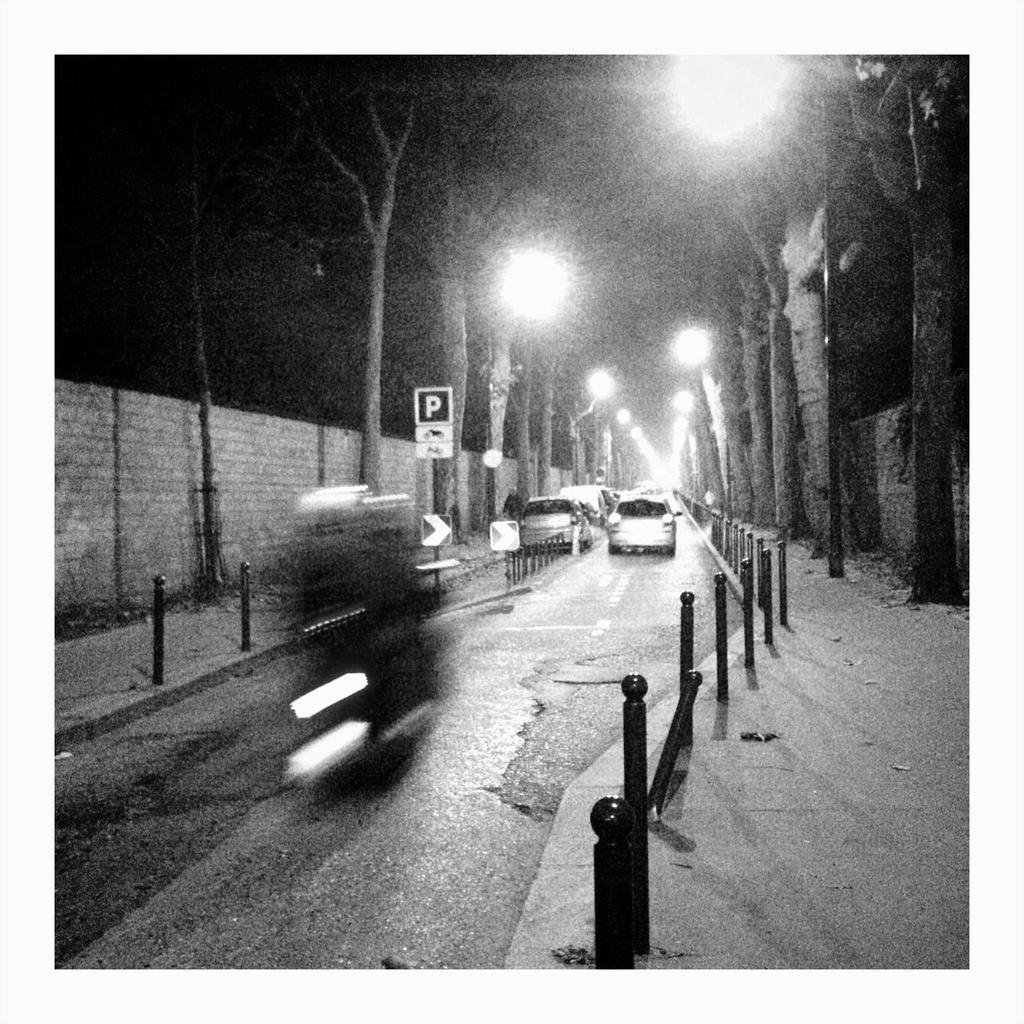Describe this image in one or two sentences. We can see vehicles on the road and poles. We can see lights, board, trees and wall. In the background it is dark. 